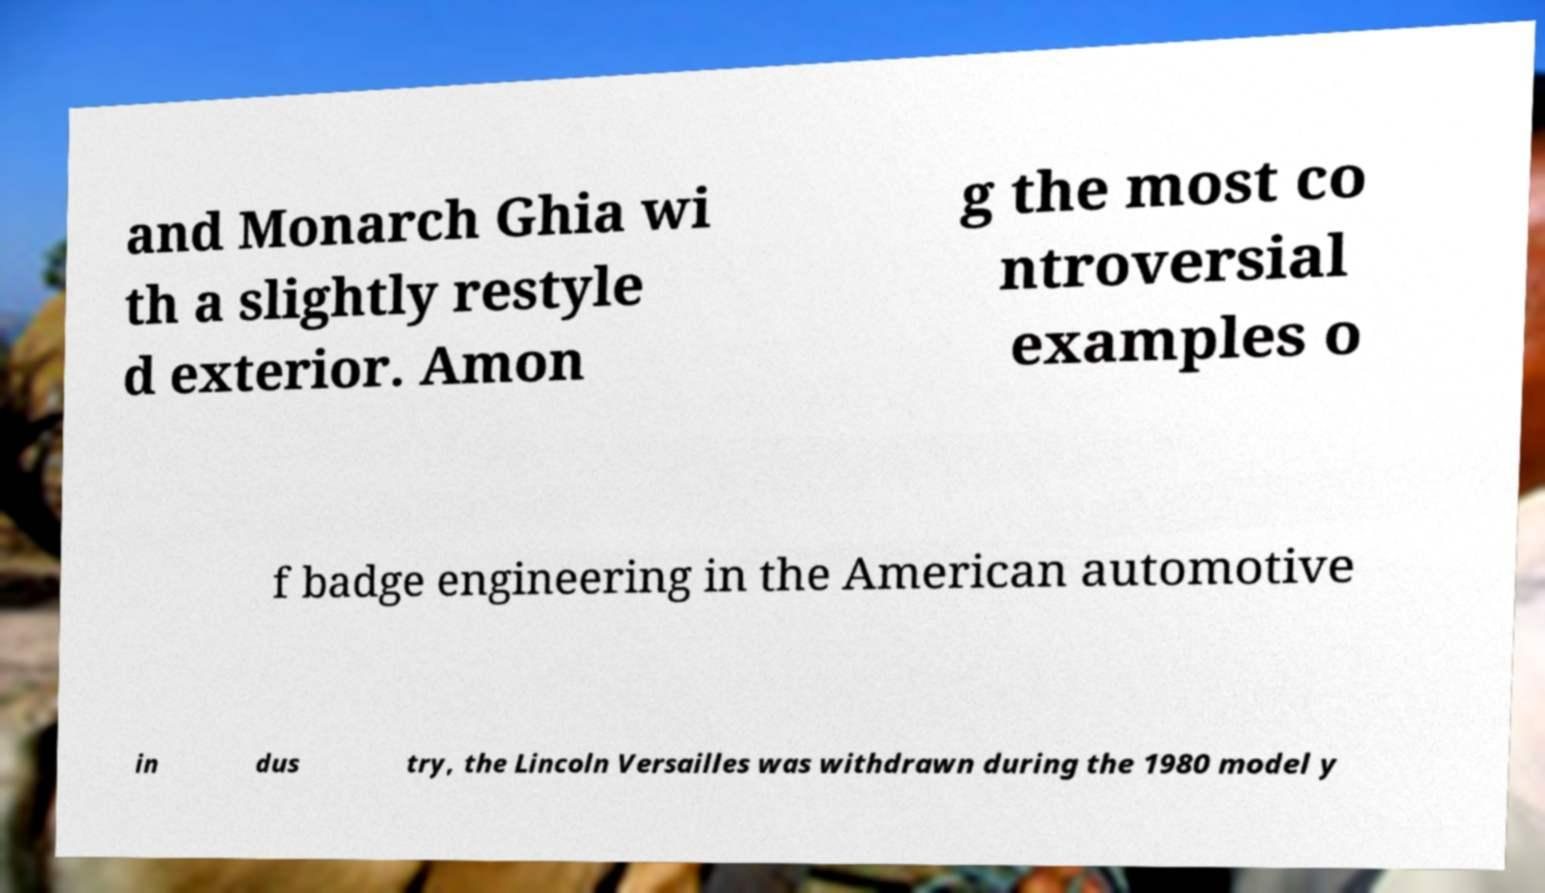Please read and relay the text visible in this image. What does it say? and Monarch Ghia wi th a slightly restyle d exterior. Amon g the most co ntroversial examples o f badge engineering in the American automotive in dus try, the Lincoln Versailles was withdrawn during the 1980 model y 